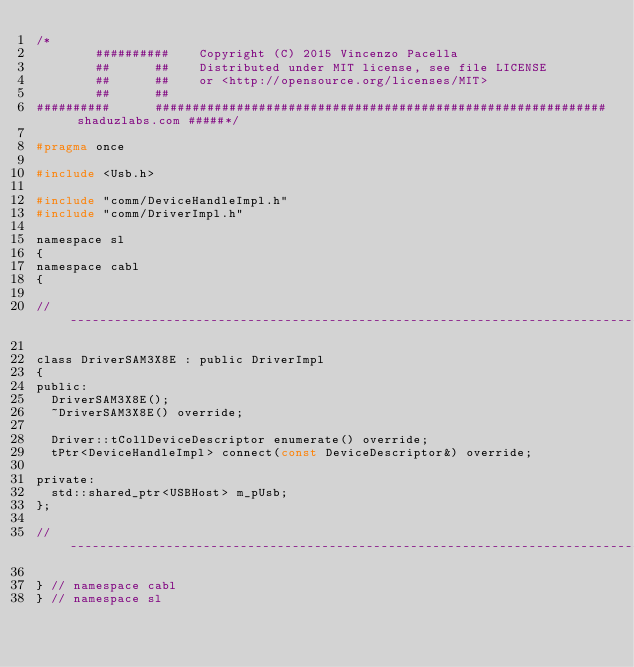Convert code to text. <code><loc_0><loc_0><loc_500><loc_500><_C_>/*
        ##########    Copyright (C) 2015 Vincenzo Pacella
        ##      ##    Distributed under MIT license, see file LICENSE
        ##      ##    or <http://opensource.org/licenses/MIT>
        ##      ##
##########      ############################################################# shaduzlabs.com #####*/

#pragma once

#include <Usb.h>

#include "comm/DeviceHandleImpl.h"
#include "comm/DriverImpl.h"

namespace sl
{
namespace cabl
{

//--------------------------------------------------------------------------------------------------

class DriverSAM3X8E : public DriverImpl
{
public:
  DriverSAM3X8E();
  ~DriverSAM3X8E() override;

  Driver::tCollDeviceDescriptor enumerate() override;
  tPtr<DeviceHandleImpl> connect(const DeviceDescriptor&) override;

private:
  std::shared_ptr<USBHost> m_pUsb;
};

//--------------------------------------------------------------------------------------------------

} // namespace cabl
} // namespace sl
</code> 